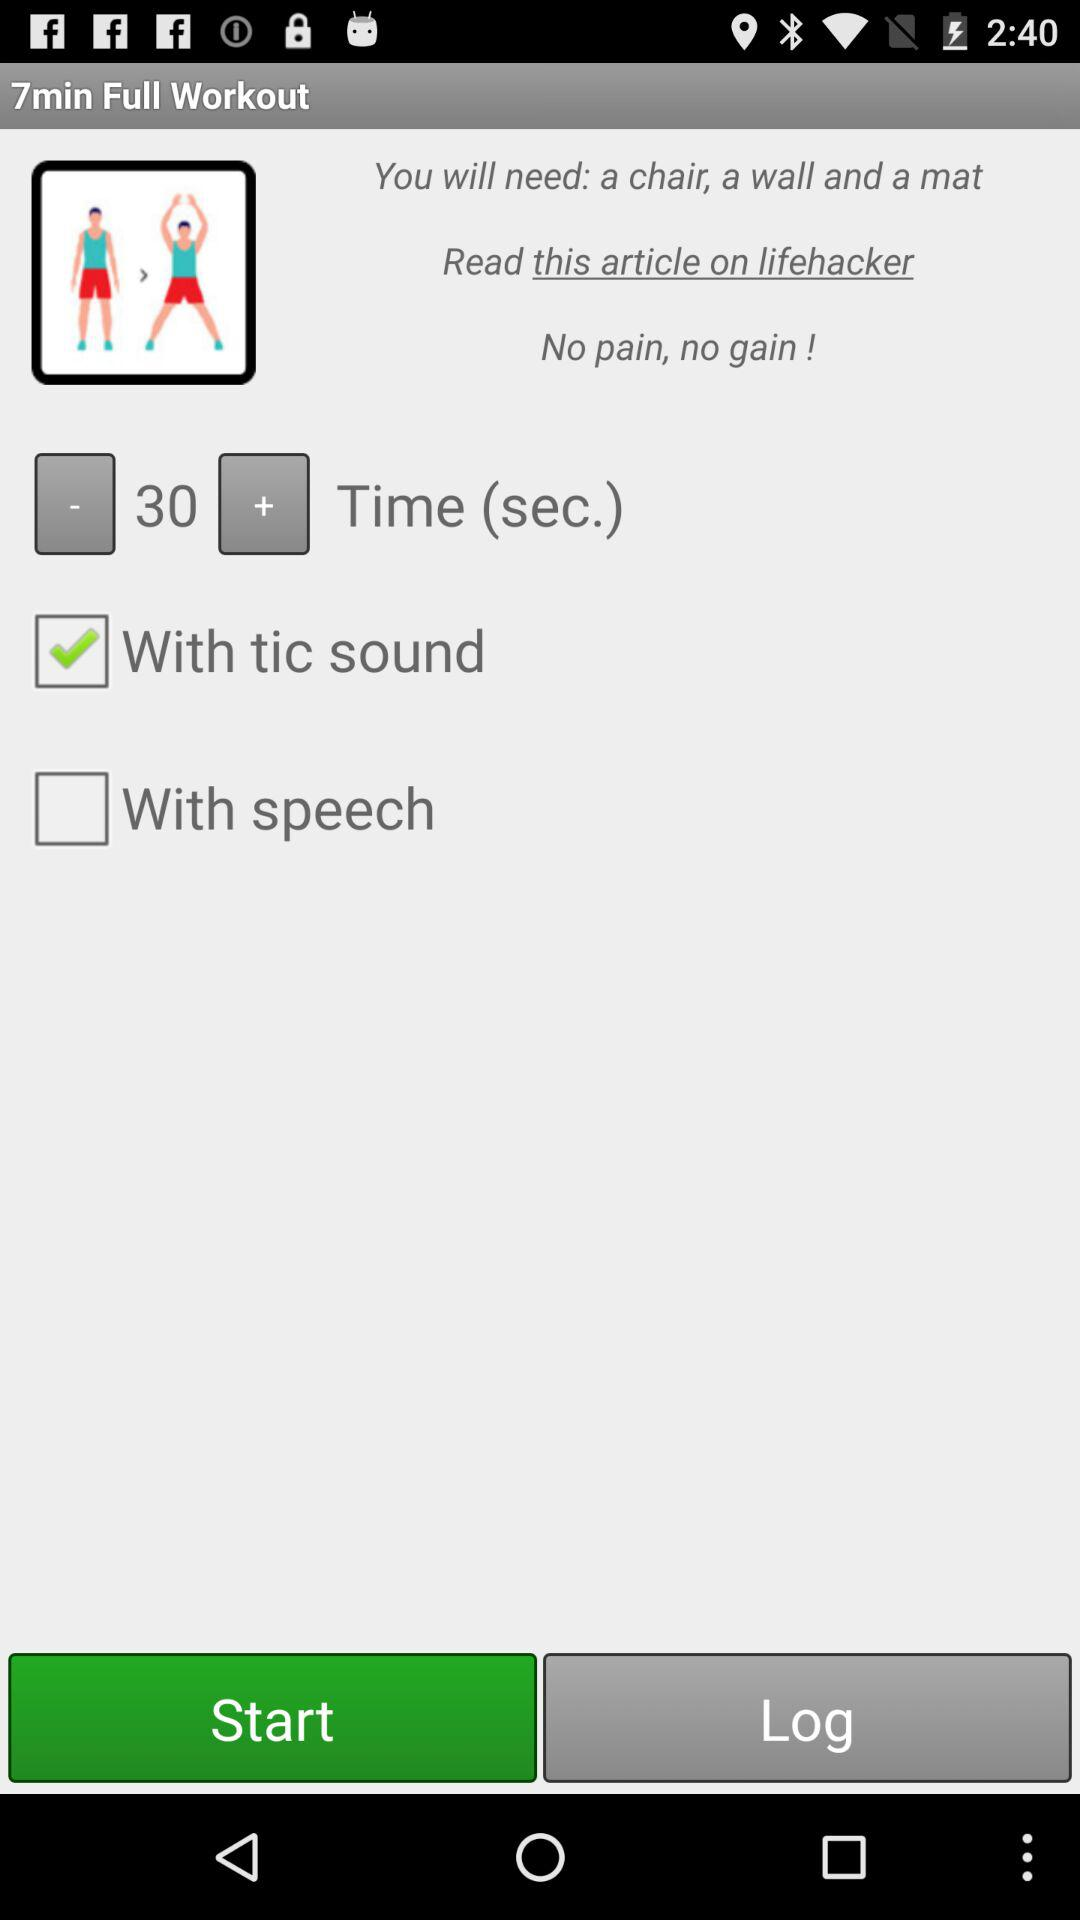What is the status of "With speech"? The status of "With speech" is "off". 